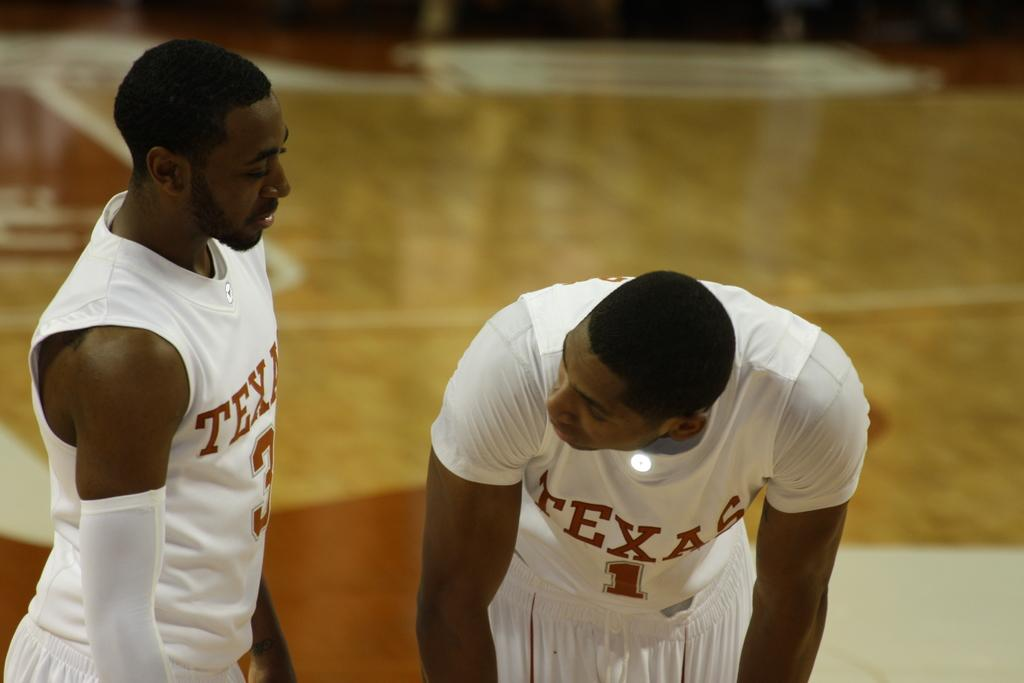<image>
Share a concise interpretation of the image provided. A couple of basketball players are on the court in Texas uniforms. 